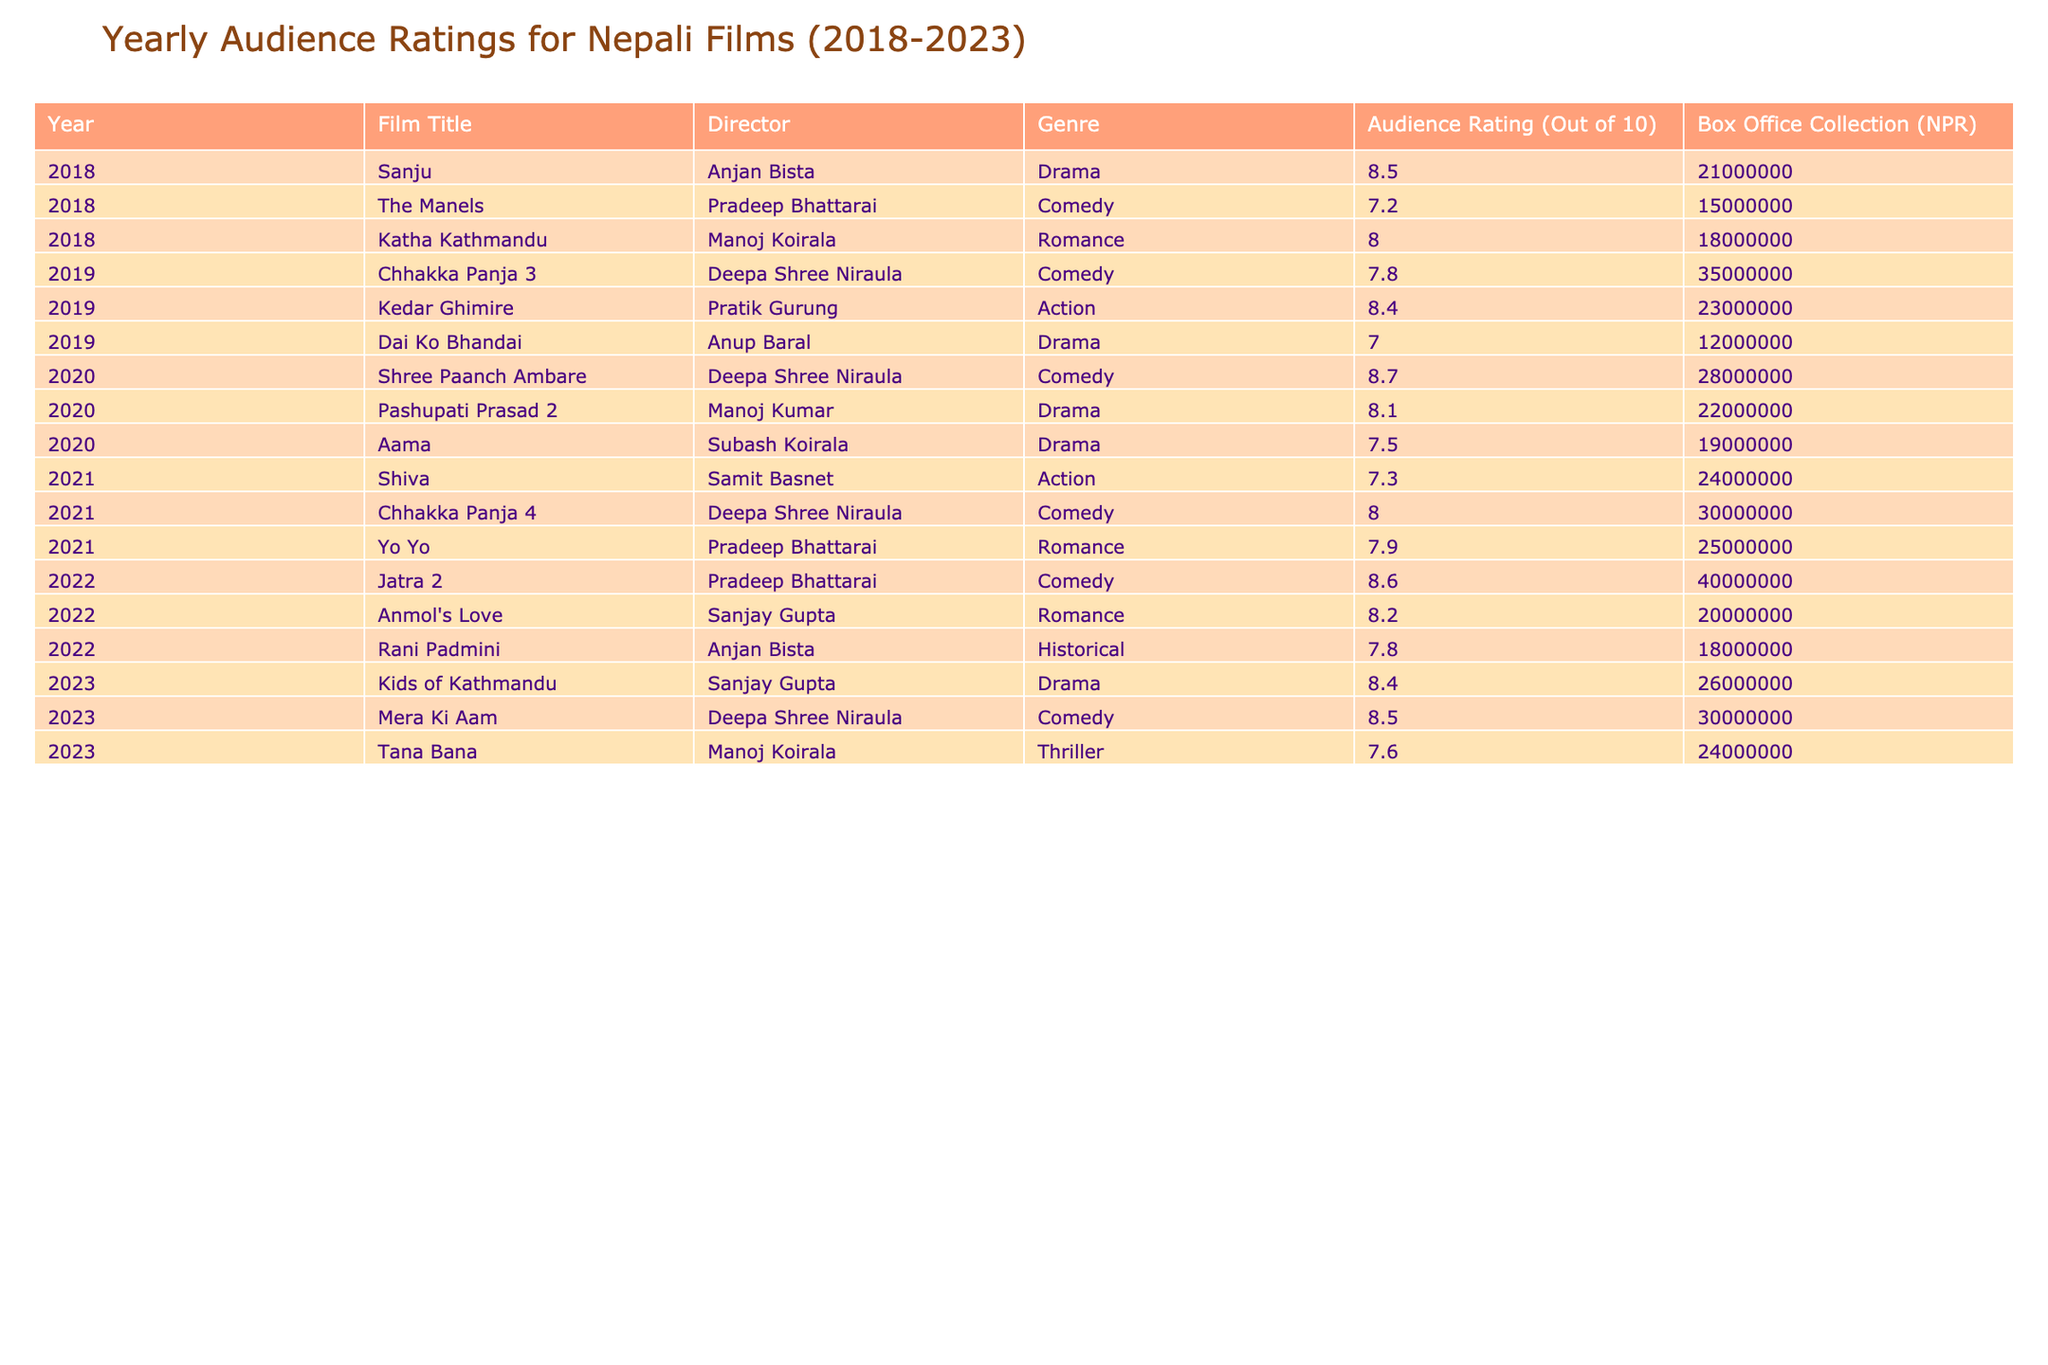What was the highest audience rating achieved by a Nepali film in 2020? In 2020, the film with the highest audience rating is "Shree Paanch Ambare," which has a rating of 8.7 out of 10.
Answer: 8.7 Which film had the lowest audience rating in 2019? The film "Dai Ko Bhandai" received the lowest audience rating in 2019, with a rating of 7.0 out of 10.
Answer: 7.0 What is the average audience rating of Nepali films in 2021? The ratings for films in 2021 are 7.3, 8.0, and 7.9. To find the average, sum these ratings (7.3 + 8.0 + 7.9 = 23.2) and divide by 3, which gives 23.2 / 3 = 7.73.
Answer: 7.73 Did any of the films released in 2022 achieve a rating of 9 or higher? Upon reviewing the ratings for films in 2022, none of them reached a rating of 9 or higher, with a maximum rating of 8.6 for "Jatra 2."
Answer: No What is the box office collection of the highest-rated film from 2018? The highest-rated film from 2018 is "Sanju," which has a box office collection of NPR 21,000,000.
Answer: NPR 21,000,000 Which Nepali film had a rating of 8.5 and was released in 2023? The films that had a rating of 8.5 released in 2023 are "Kids of Kathmandu" and "Mera Ki Aam."
Answer: "Kids of Kathmandu" and "Mera Ki Aam" What was the total box office collection for Nepali films in 2019? The box office collections for Nepali films in 2019 are NPR 35,000,000 for "Chhakka Panja 3," NPR 23,000,000 for "Kedar Ghimire," and NPR 12,000,000 for "Dai Ko Bhandai." Summing these totals gives NPR 35,000,000 + 23,000,000 + 12,000,000 = NPR 70,000,000.
Answer: NPR 70,000,000 Which genre had the highest average audience rating across all years presented? To find the genre with the highest average rating, we must consider each genre's films and their ratings. For example, Comedy films average to 8.17 while Drama averages to 7.76, and Action averages to 7.65 among other genres. Comparing these, Comedy has the highest average rating of 8.17.
Answer: Comedy Was there any increase in box office collection for Nepali films from 2020 to 2021? In 2020, the total box office collection is NPR 78,000,000, while for 2021, it totals NPR 21,000,000 (Shiva) + 30,000,000 (Chhakka Panja 4) + 25,000,000 (Yo Yo) = NPR 76,000,000. Comparing these figures shows a decrease from 2020 to 2021.
Answer: No 